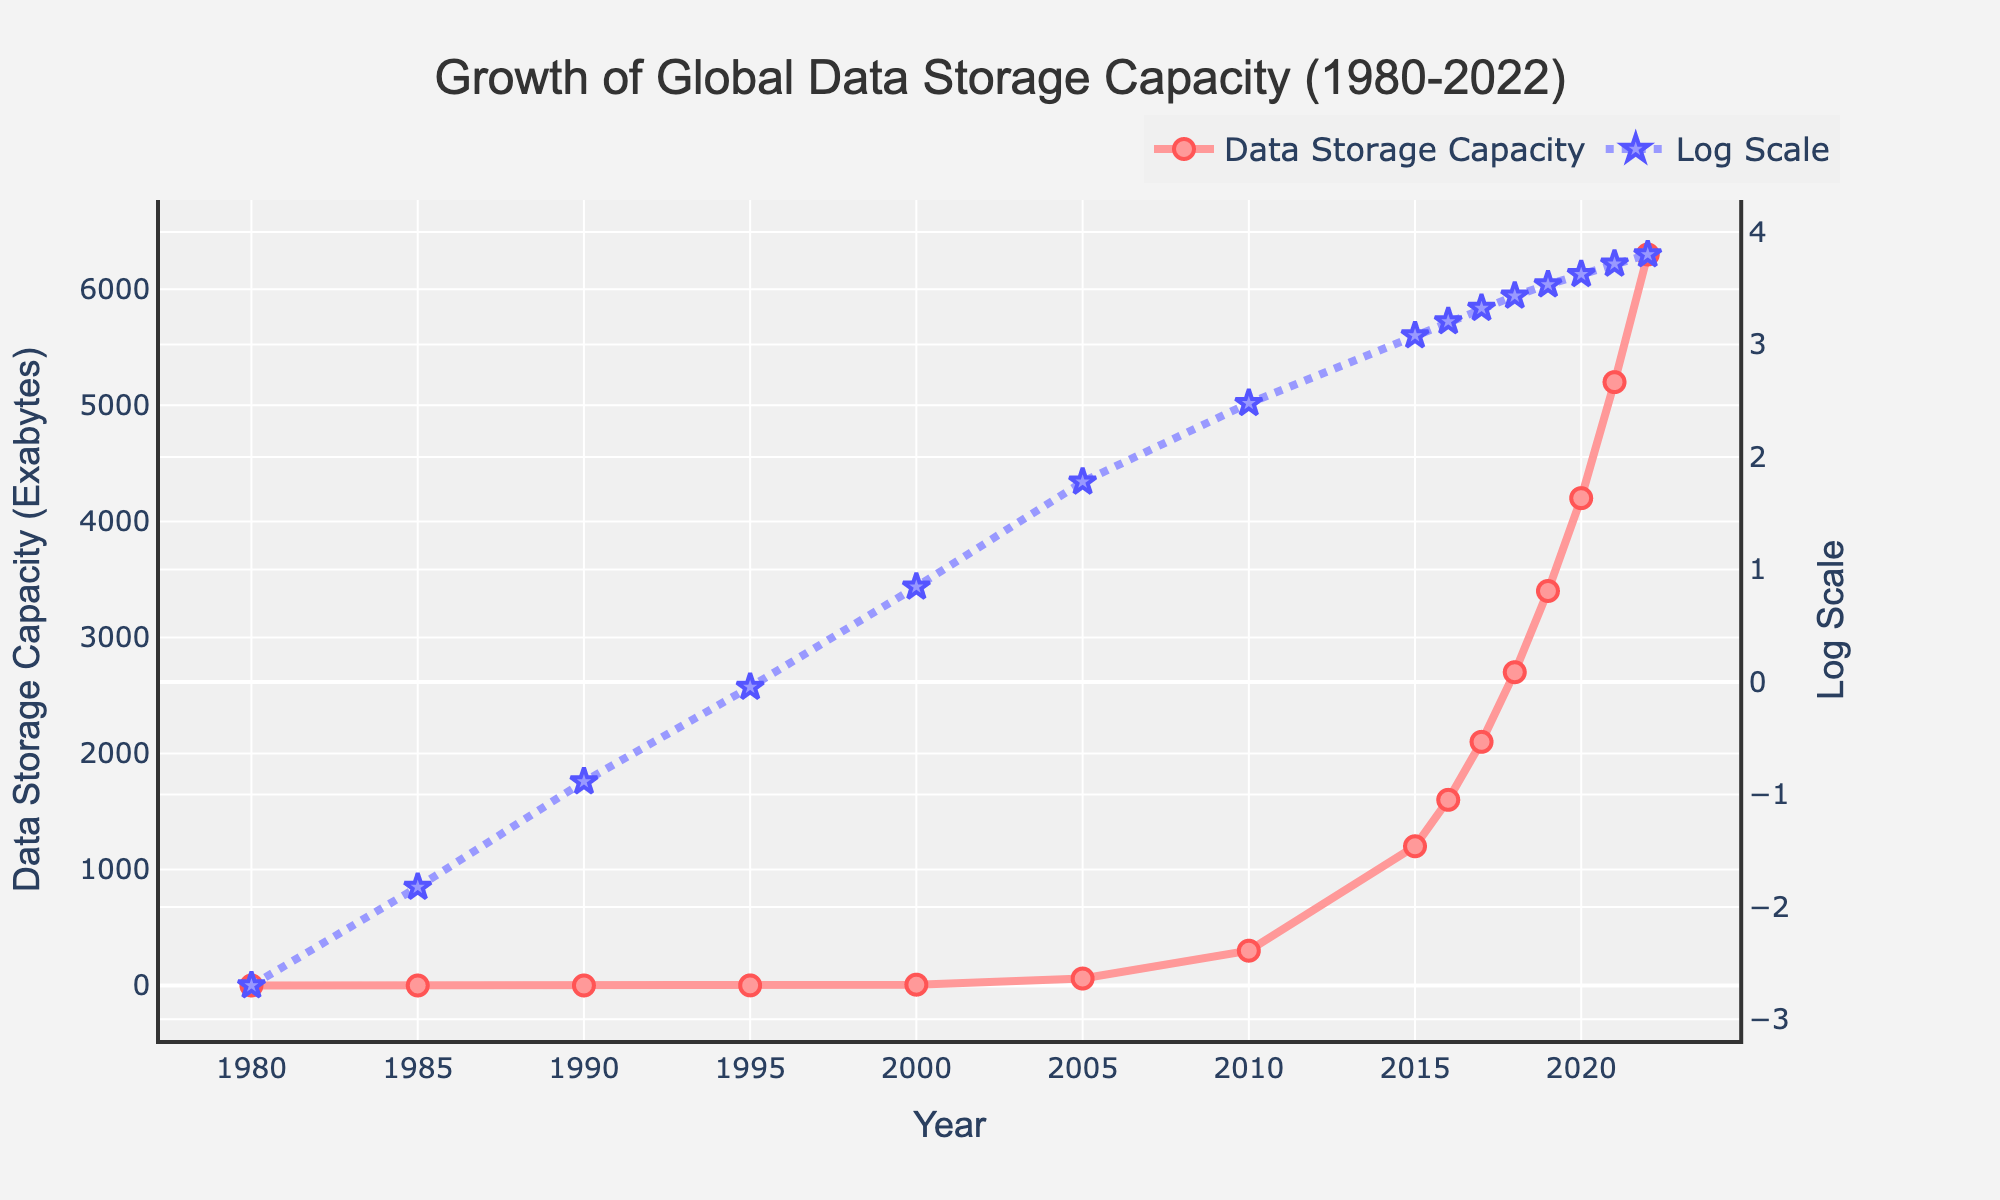What is the data storage capacity in 1985? From the chart, locate the year 1985 on the x-axis, and trace upward to find the corresponding point on the "Data Storage Capacity" line, which shows the value.
Answer: 0.015 Exabytes Which year shows a higher data storage capacity, 2005 or 2010? By comparing the data points for 2005 and 2010 on the "Data Storage Capacity" line, identify that 2010 has a higher value than 2005.
Answer: 2010 How much did the global data storage capacity increase from 1980 to 2022? Subtract the 1980 value from the 2022 value. Locate 1980 (0.002 Exabytes) and 2022 (6300 Exabytes) on the plot. The increase is 6300 - 0.002 = 6299.998 Exabytes.
Answer: 6299.998 Exabytes In which year did the global data storage capacity first exceed 1000 Exabytes? Scan the plot to find the year where the data storage capacity line first crosses the 1000 Exabytes mark. The point just below and above 1000 Exabytes is between 2010 (300 Exabytes) and 2015 (1200 Exabytes), so it is in 2015.
Answer: 2015 Identify the year when the log scale crosses 3 on the y-axis for the first time. Locate the line representing "Log Scale" and find the point where it first crosses the value of 3 on the y-axis. This happens between 1995 (log10(0.9)= -0.045) and 2000 (log10(7) ≈ 0.845), so it's around the year 2000, given the linear scale on the original trace maps that around 100 Exabytes crosses around 3.
Answer: Around 2005 Calculate the average data storage capacity between 2000 and 2010. Identify the capacities for 2000 (7 Exabytes), 2005 (60 Exabytes), and 2010 (300 Exabytes). The average is (7 + 60 + 300) / 3 = 367 / 3 ≈ 122.33 Exabytes.
Answer: 122.33 Exabytes Which year shows a more significant increase in data storage capacity, from 1985 to 1990 or from 1990 to 1995? Calculate the increases for both periods and compare them. From 1985 to 1990: 0.13 - 0.015 = 0.115 Exabytes. From 1990 to 1995: 0.9 - 0.13 = 0.77 Exabytes. 1990 to 1995 has a larger increase.
Answer: 1990 to 1995 What is the data storage capacity for the year closest to 2005 on the log scale? Locate 2005 on the x-axis, trace counterclockwise on the y-axis of the log scale to find the corresponding point; the log10 value for 2005 (60 Exabytes) is log10(60) = 1.78.
Answer: 1.78 